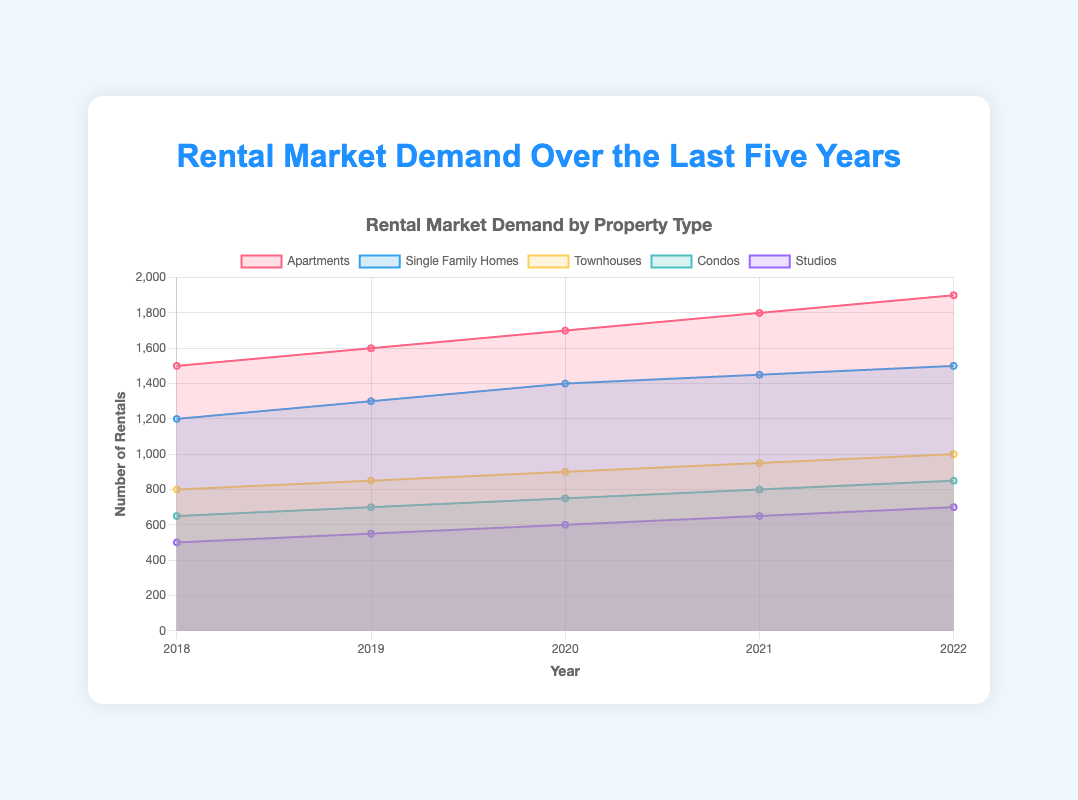what is the highest number of rentals achieved for any property type and in which year did this occur? The highest number of rentals appears for Apartments in 2022 with a count of 1900. This can be observed from the peaks of the colored areas in the chart where the Apartments section is largest.
Answer: Apartments in 2022, 1900 how many total property types are displayed in the chart? By counting the colored areas and listing the legend names, we can identify there are five property types displayed: Apartments, Single Family Homes, Townhouses, Condos, and Studios.
Answer: 5 which property type shows the most consistent annual increase in demand? Examining the trends across each year, Apartments show a steady increase every year from 2018 to 2022 without any decline or plateau, indicating the most consistent annual increase.
Answer: Apartments what is the difference in rental demand between Single Family Homes and Condos in 2021? In 2021, the demand for Single Family Homes is 1450, and for Condos, it is 800. The difference is calculated as 1450 - 800 = 650.
Answer: 650 how has demand for Studios changed from 2018 to 2022? The demand for Studios has increased from 500 in 2018 to 700 in 2022. This is observed by checking the data points for Studios at both these years.
Answer: Increased by 200 which two property types had the closest rental demand values in 2019? In 2019, the values for Single Family Homes and Condos are 1300 and 700 respectively. By checking other pairs, the closest pair is Condos and Studios with values 700 and 550, the difference being 150.
Answer: Condos and Studios what's the total rental demand for all property types in the year 2020? Summing the rental demands for all property types in 2020: Apartments (1700) + Single Family Homes (1400) + Townhouses (900) + Condos (750) + Studios (600) = 5350.
Answer: 5350 which property type experienced the largest increase in demand from 2018 to 2019? Comparing the increases: Apartments from 1500 to 1600 (+100), Single Family Homes from 1200 to 1300 (+100), Townhouses from 800 to 850 (+50), Condos from 650 to 700 (+50), and Studios from 500 to 550 (+50), both Apartments and Single Family Homes had the largest increase (+100).
Answer: Apartments and Single Family Homes is there a year in which the demand for Townhouses surpassed Single Family Homes? Examining each year, Single Family Homes always have a higher demand than Townhouses, as seen by their positions on the y-axis.
Answer: No what trend is indicated by the rental demand for Condos across the years? The rental demand for Condos shows a steady increase each year from 2018 to 2022, indicated by a consistent upwards trend line.
Answer: Steady increase 